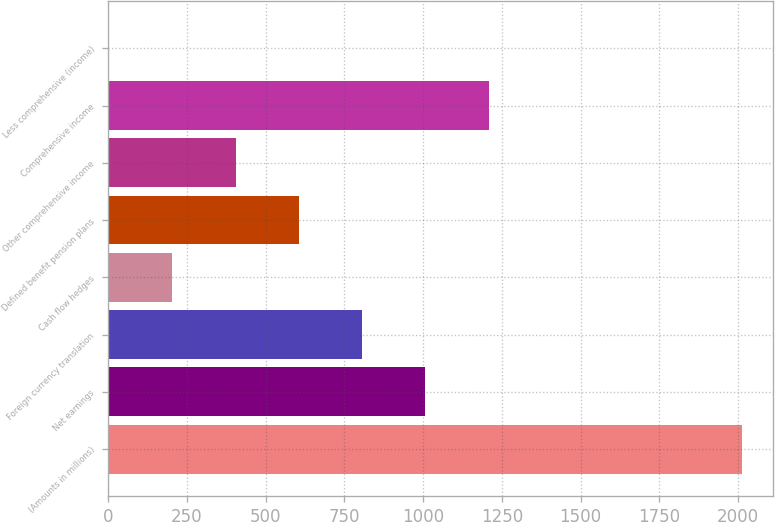<chart> <loc_0><loc_0><loc_500><loc_500><bar_chart><fcel>(Amounts in millions)<fcel>Net earnings<fcel>Foreign currency translation<fcel>Cash flow hedges<fcel>Defined benefit pension plans<fcel>Other comprehensive income<fcel>Comprehensive income<fcel>Less comprehensive (income)<nl><fcel>2012<fcel>1007.2<fcel>806.24<fcel>203.36<fcel>605.28<fcel>404.32<fcel>1208.16<fcel>2.4<nl></chart> 